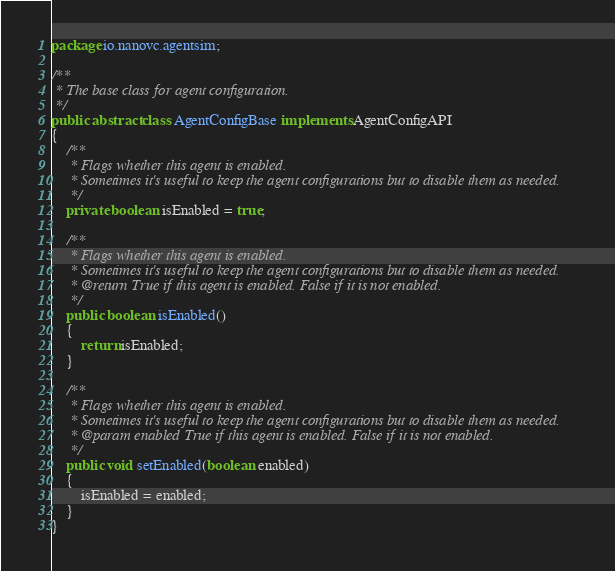Convert code to text. <code><loc_0><loc_0><loc_500><loc_500><_Java_>package io.nanovc.agentsim;

/**
 * The base class for agent configuration.
 */
public abstract class AgentConfigBase implements AgentConfigAPI
{
    /**
     * Flags whether this agent is enabled.
     * Sometimes it's useful to keep the agent configurations but to disable them as needed.
     */
    private boolean isEnabled = true;

    /**
     * Flags whether this agent is enabled.
     * Sometimes it's useful to keep the agent configurations but to disable them as needed.
     * @return True if this agent is enabled. False if it is not enabled.
     */
    public boolean isEnabled()
    {
        return isEnabled;
    }

    /**
     * Flags whether this agent is enabled.
     * Sometimes it's useful to keep the agent configurations but to disable them as needed.
     * @param enabled True if this agent is enabled. False if it is not enabled.
     */
    public void setEnabled(boolean enabled)
    {
        isEnabled = enabled;
    }
}
</code> 